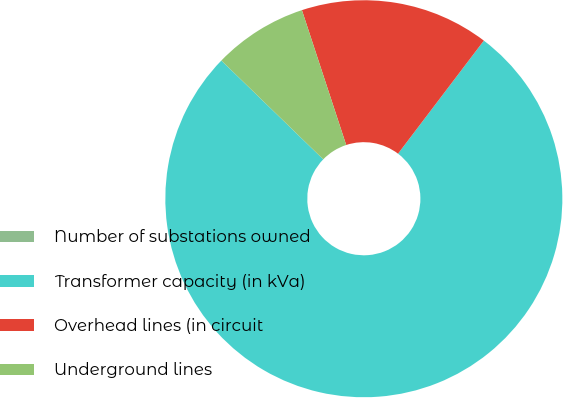Convert chart. <chart><loc_0><loc_0><loc_500><loc_500><pie_chart><fcel>Number of substations owned<fcel>Transformer capacity (in kVa)<fcel>Overhead lines (in circuit<fcel>Underground lines<nl><fcel>0.0%<fcel>76.92%<fcel>15.38%<fcel>7.69%<nl></chart> 